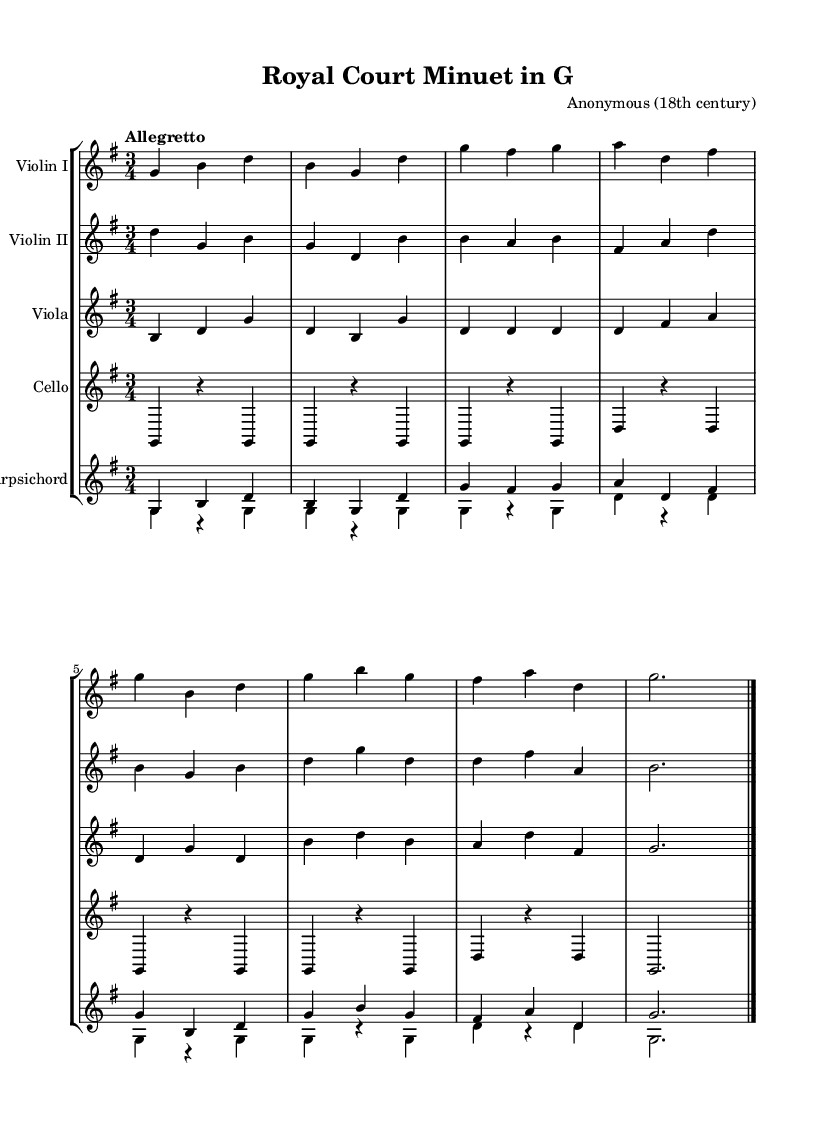What is the key signature of this music? The key signature is G major, which has one sharp (F#). This can be found at the beginning of the sheet music.
Answer: G major What is the time signature of this music? The time signature is 3/4, which indicates three beats per measure and is noted at the beginning of the score.
Answer: 3/4 What is the tempo marking of this piece? The tempo marking indicates "Allegretto," which suggests a moderately fast tempo, noted in the score at the beginning.
Answer: Allegretto How many instrumental parts are there in this score? There are five instrumental parts listed: Violin I, Violin II, Viola, Cello, and Harpsichord. This is evident from the alignment of different staves in the score.
Answer: Five What instrument typically plays the continuo in Baroque music represented here? The harpsichord typically plays the continuo in Baroque music, evidenced by its specific staff grouping in the score.
Answer: Harpsichord Which instrument plays the highest pitch in the ensemble? The first violin (Violin I) plays the highest pitch among the ensemble instruments, by observing the relative pitch location of the notes on the staff.
Answer: Violin I What musical form is commonly used in Baroque chamber music like this minuet? The minuet is a common dance form in Baroque chamber music, which is characterized by its triple meter and elegant style, as suggested by the title.
Answer: Minuet 